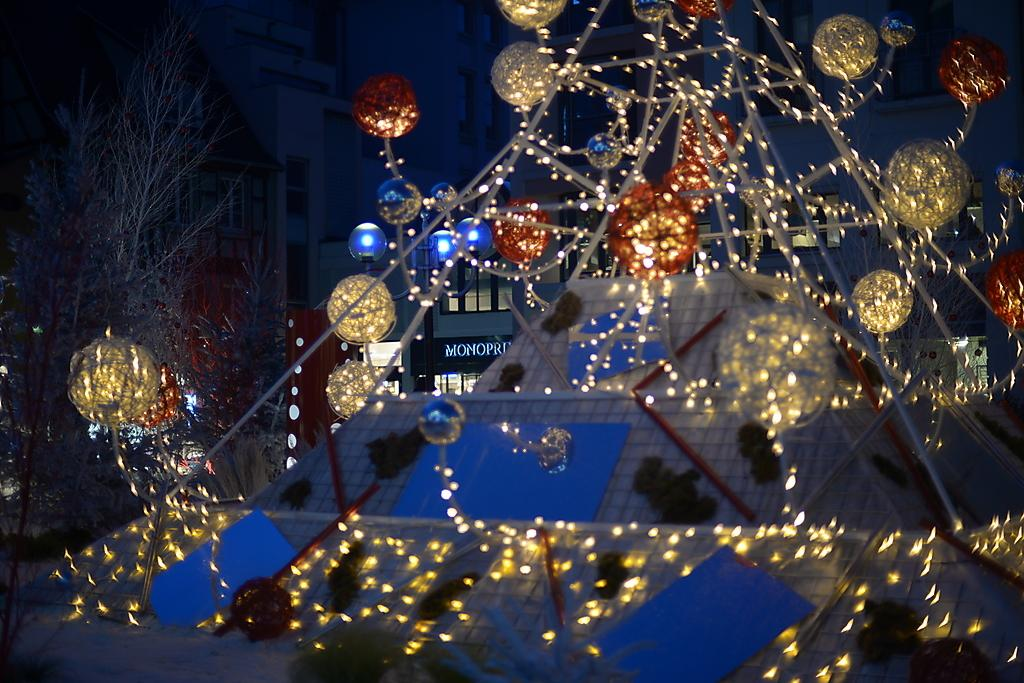What type of lighting can be seen in the image? There are decorative lights in the image. What type of natural elements are present in the image? There are trees in the image. What type of man-made structures can be seen in the background of the image? There are buildings visible in the background of the image. Can you tell me how many needles are hanging from the trees in the image? There are no needles present in the image; it features decorative lights and trees. What type of lead is being used to connect the buildings in the image? There is no mention of lead or any type of connection between the buildings in the image. 